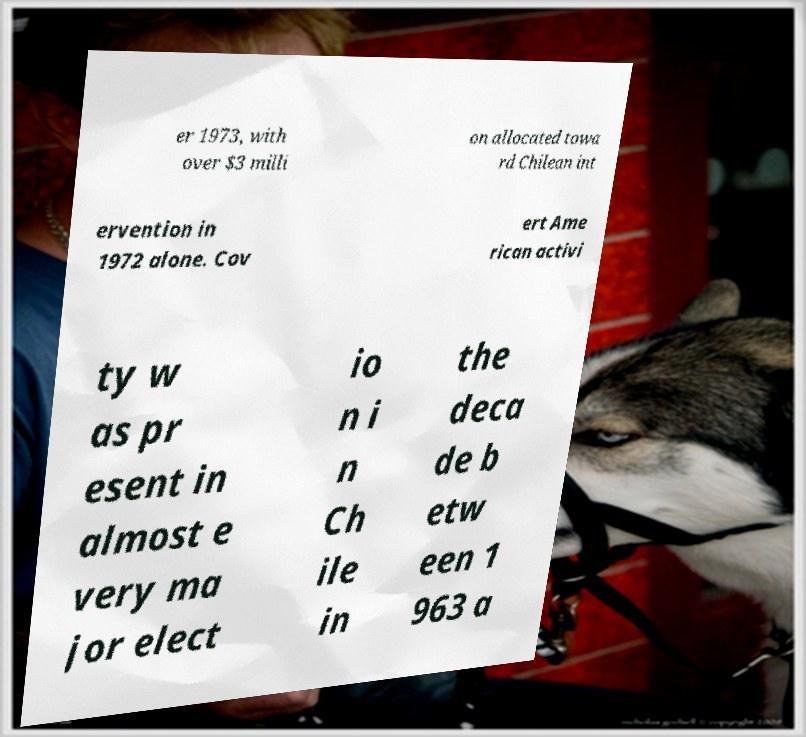I need the written content from this picture converted into text. Can you do that? er 1973, with over $3 milli on allocated towa rd Chilean int ervention in 1972 alone. Cov ert Ame rican activi ty w as pr esent in almost e very ma jor elect io n i n Ch ile in the deca de b etw een 1 963 a 